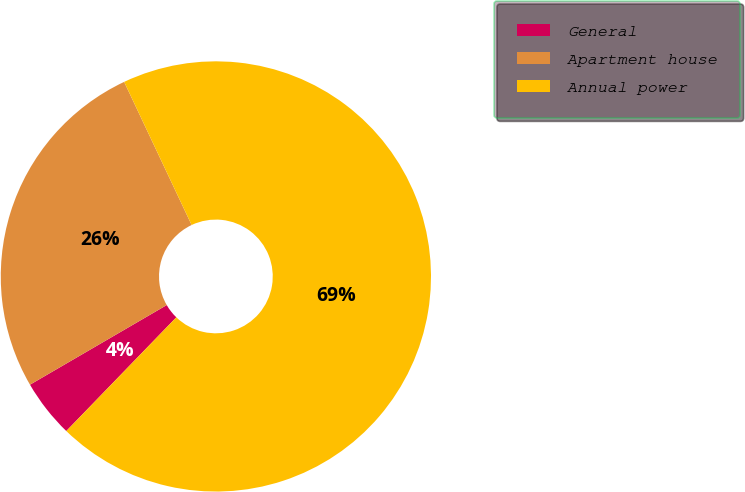Convert chart to OTSL. <chart><loc_0><loc_0><loc_500><loc_500><pie_chart><fcel>General<fcel>Apartment house<fcel>Annual power<nl><fcel>4.37%<fcel>26.38%<fcel>69.25%<nl></chart> 